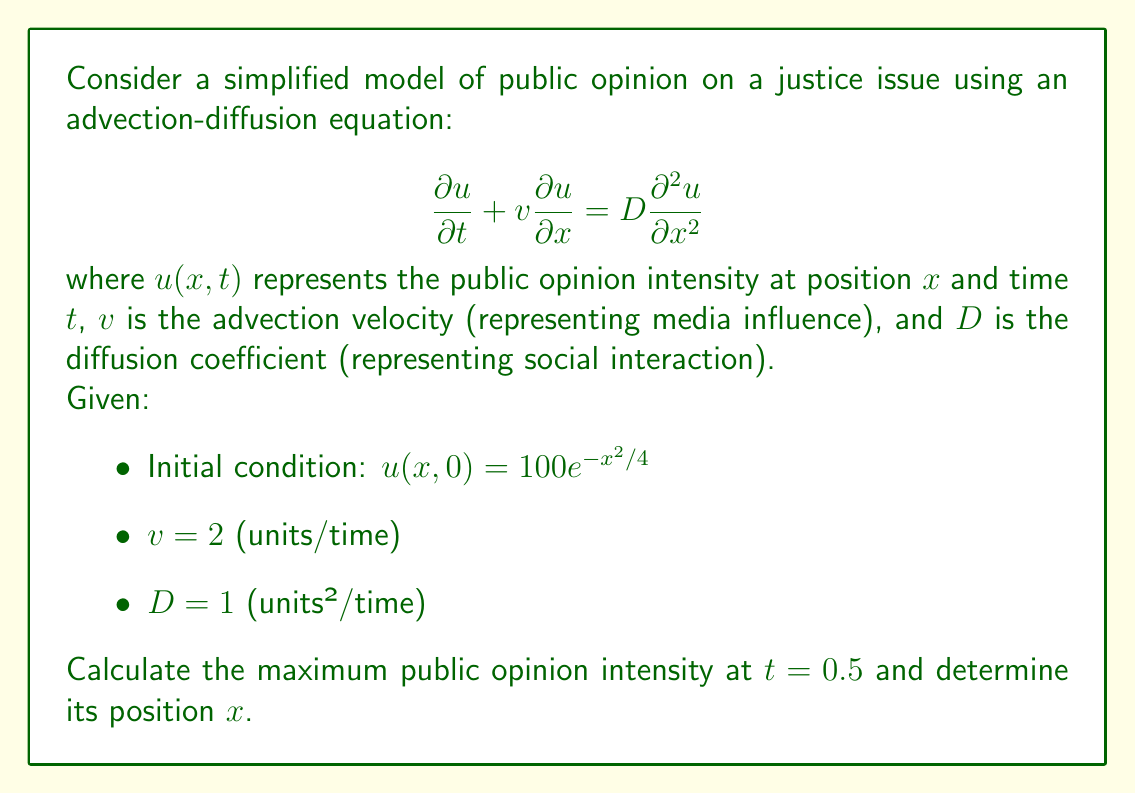Can you answer this question? To solve this problem, we need to use the fundamental solution of the advection-diffusion equation and apply it to our initial condition. The steps are as follows:

1) The fundamental solution for the advection-diffusion equation is:

   $$u(x,t) = \frac{1}{\sqrt{4\pi Dt}} \int_{-\infty}^{\infty} u_0(y) \exp\left(-\frac{(x-y-vt)^2}{4Dt}\right) dy$$

   where $u_0(y)$ is the initial condition.

2) In our case, $u_0(y) = 100e^{-y^2/4}$. Substituting this and the given values:

   $$u(x,0.5) = \frac{100}{\sqrt{2\pi}} \int_{-\infty}^{\infty} e^{-y^2/4} \exp\left(-\frac{(x-y-1)^2}{2}\right) dy$$

3) This integral can be evaluated to:

   $$u(x,0.5) = \frac{100}{\sqrt{3}} \exp\left(-\frac{(x-1)^2}{6}\right)$$

4) To find the maximum intensity and its position, we need to find the maximum of this function. The maximum will occur where $x-1 = 0$, i.e., at $x = 1$.

5) The maximum intensity is therefore:

   $$u_{max} = u(1,0.5) = \frac{100}{\sqrt{3}} \approx 57.74$$

Thus, the maximum public opinion intensity at $t = 0.5$ is approximately 57.74, and it occurs at position $x = 1$.
Answer: Maximum intensity: $\frac{100}{\sqrt{3}} \approx 57.74$
Position: $x = 1$ 